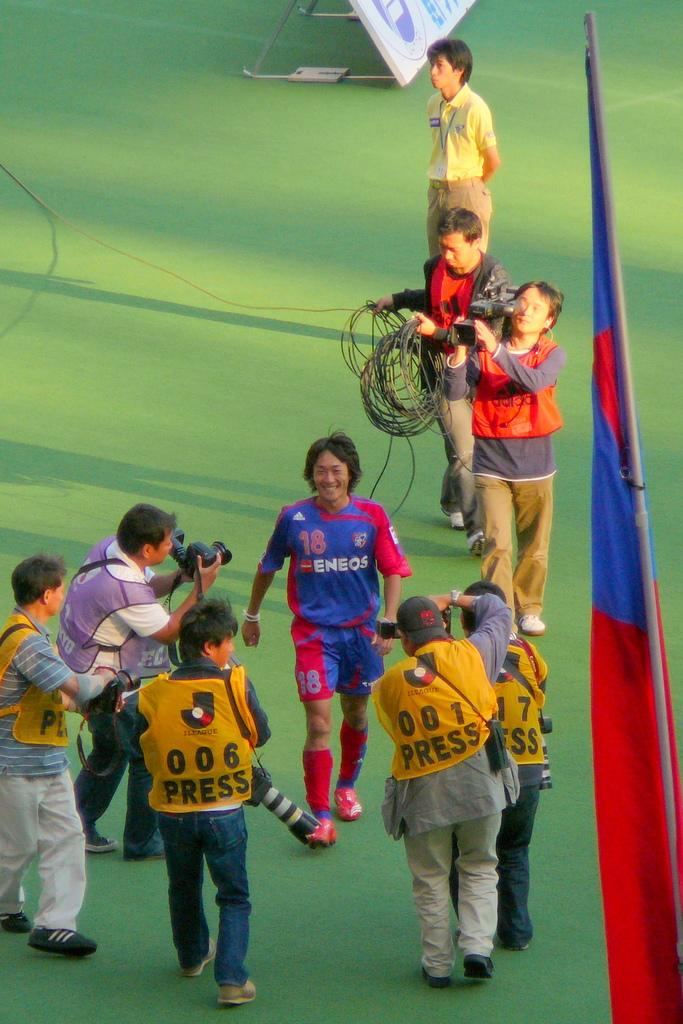How many people are in the image? There are people in the image, but the exact number is not specified. What is the man doing in the image? The man is walking and smiling in the image. What are the people holding in the image? The people are holding cameras in the image. What can be seen on the ground in the image? There are cables visible on the ground in the image. What is present in the background of the image? There is a flag and a hoarding on a green surface in the background of the image. What is the stand used for in the image? The stand on the green surface is not specified, but it could be used for various purposes. What time of day is it in the image, and how does the man's knee feel? The time of day is not specified in the image, and there is no information about the man's knee. What is the man using to rake leaves in the image? There is no rake present in the image. 